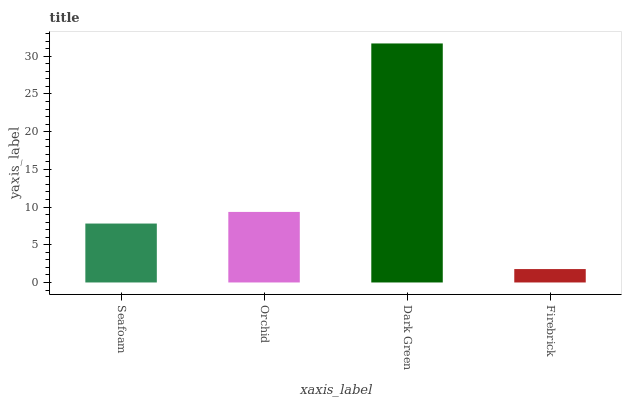Is Firebrick the minimum?
Answer yes or no. Yes. Is Dark Green the maximum?
Answer yes or no. Yes. Is Orchid the minimum?
Answer yes or no. No. Is Orchid the maximum?
Answer yes or no. No. Is Orchid greater than Seafoam?
Answer yes or no. Yes. Is Seafoam less than Orchid?
Answer yes or no. Yes. Is Seafoam greater than Orchid?
Answer yes or no. No. Is Orchid less than Seafoam?
Answer yes or no. No. Is Orchid the high median?
Answer yes or no. Yes. Is Seafoam the low median?
Answer yes or no. Yes. Is Seafoam the high median?
Answer yes or no. No. Is Orchid the low median?
Answer yes or no. No. 